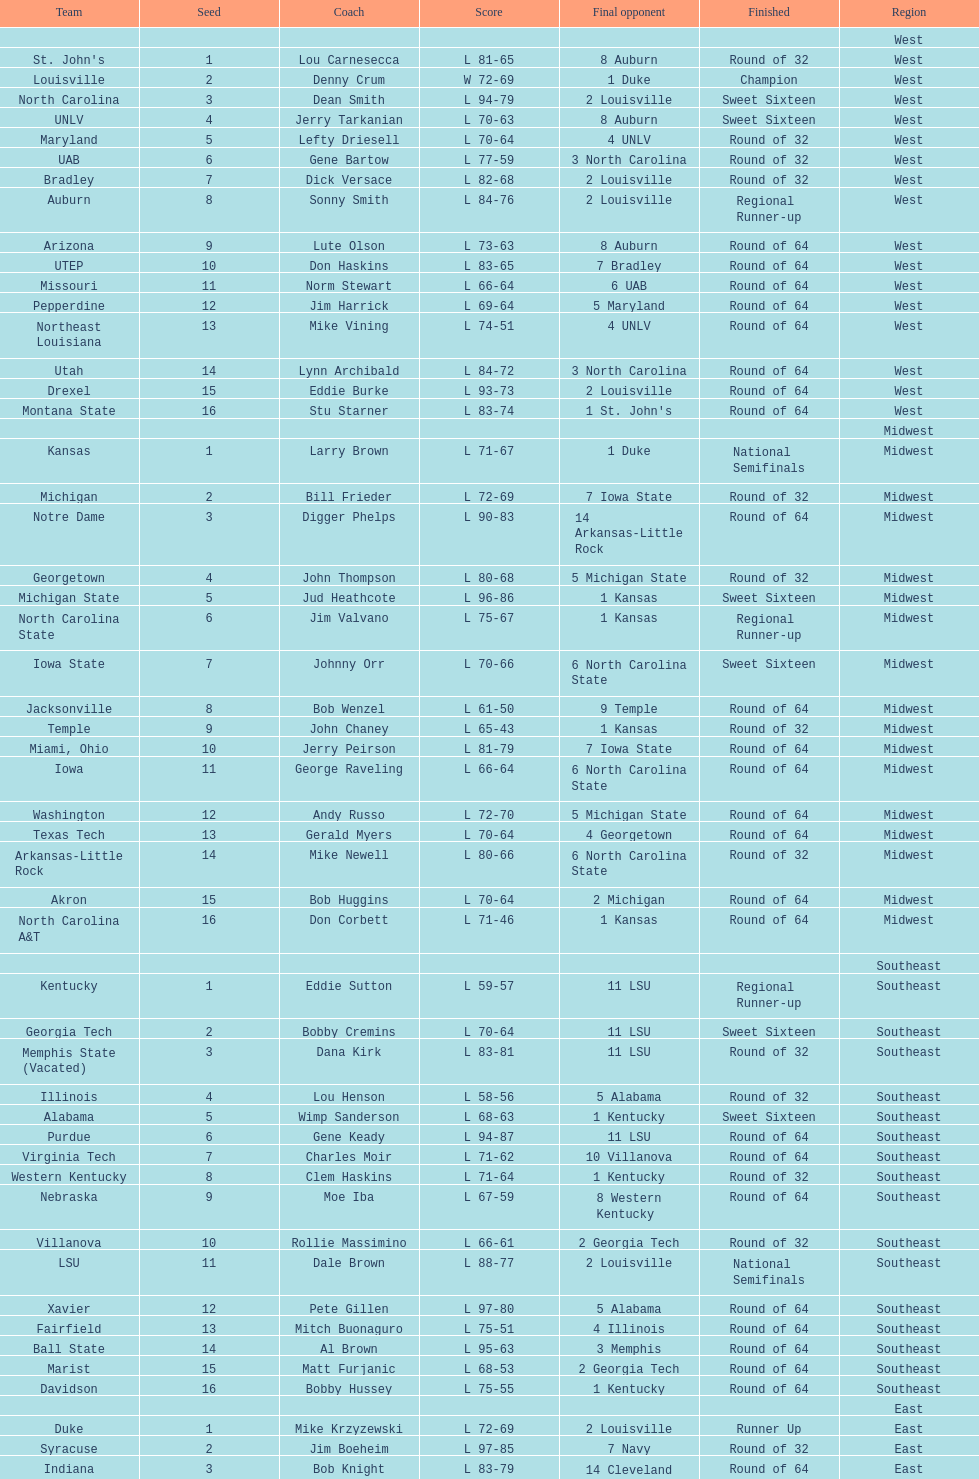Which team went finished later in the tournament, st. john's or north carolina a&t? North Carolina A&T. 